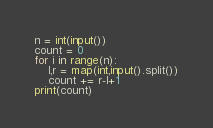Convert code to text. <code><loc_0><loc_0><loc_500><loc_500><_Python_>n = int(input())
count = 0
for i in range(n):
    l,r = map(int,input().split())
    count += r-l+1
print(count)</code> 